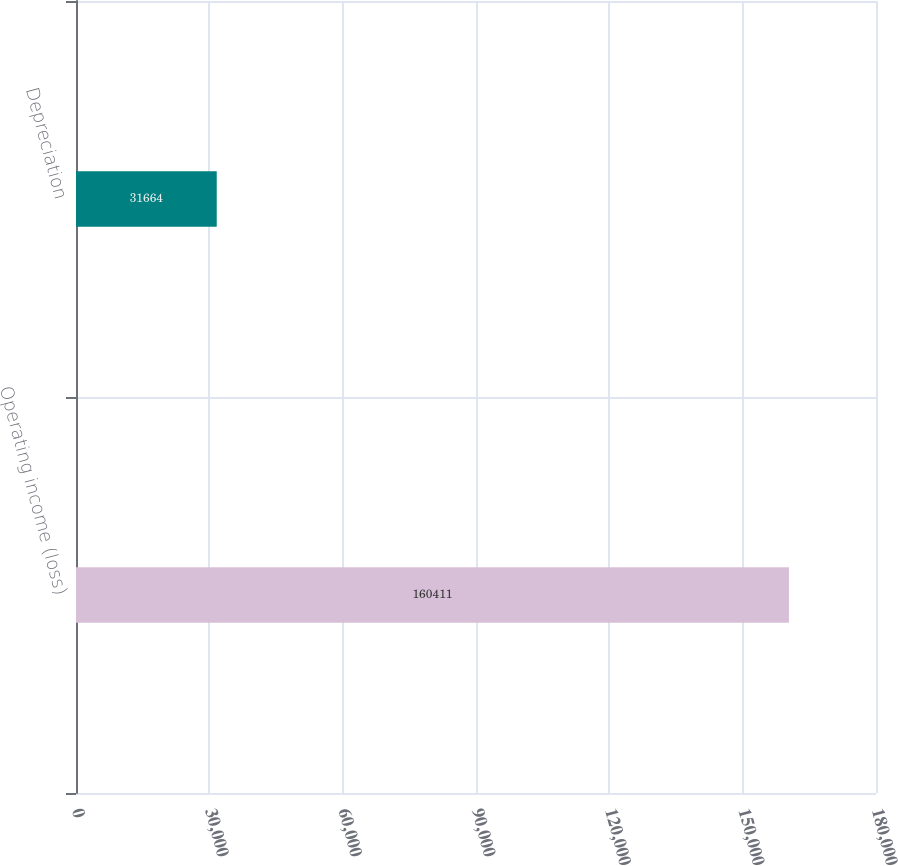<chart> <loc_0><loc_0><loc_500><loc_500><bar_chart><fcel>Operating income (loss)<fcel>Depreciation<nl><fcel>160411<fcel>31664<nl></chart> 